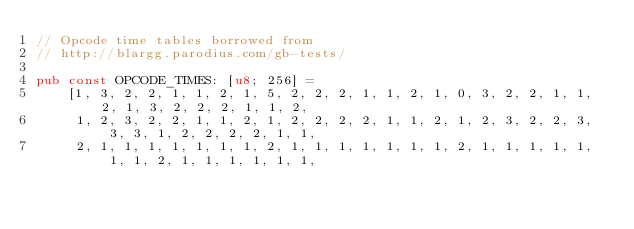Convert code to text. <code><loc_0><loc_0><loc_500><loc_500><_Rust_>// Opcode time tables borrowed from
// http://blargg.parodius.com/gb-tests/

pub const OPCODE_TIMES: [u8; 256] =
    [1, 3, 2, 2, 1, 1, 2, 1, 5, 2, 2, 2, 1, 1, 2, 1, 0, 3, 2, 2, 1, 1, 2, 1, 3, 2, 2, 2, 1, 1, 2,
     1, 2, 3, 2, 2, 1, 1, 2, 1, 2, 2, 2, 2, 1, 1, 2, 1, 2, 3, 2, 2, 3, 3, 3, 1, 2, 2, 2, 2, 1, 1,
     2, 1, 1, 1, 1, 1, 1, 1, 2, 1, 1, 1, 1, 1, 1, 1, 2, 1, 1, 1, 1, 1, 1, 1, 2, 1, 1, 1, 1, 1, 1,</code> 